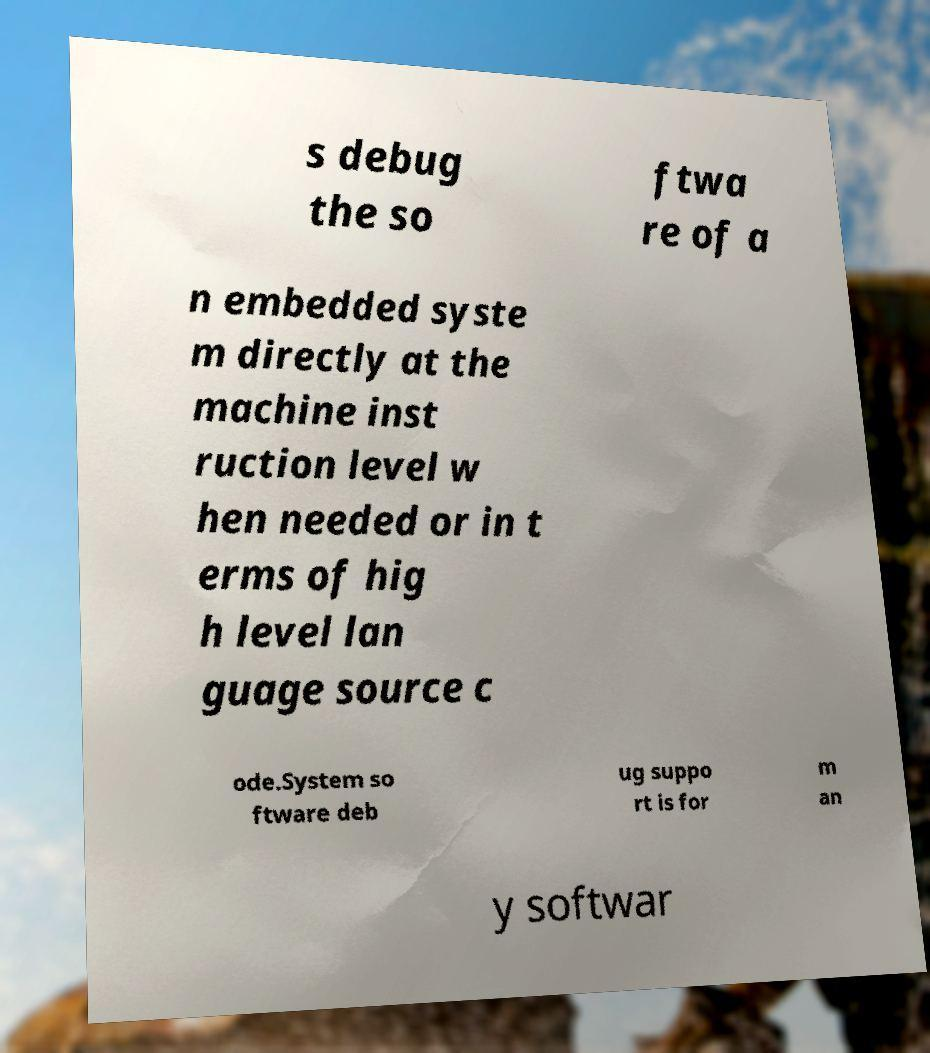Can you accurately transcribe the text from the provided image for me? s debug the so ftwa re of a n embedded syste m directly at the machine inst ruction level w hen needed or in t erms of hig h level lan guage source c ode.System so ftware deb ug suppo rt is for m an y softwar 